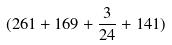Convert formula to latex. <formula><loc_0><loc_0><loc_500><loc_500>( 2 6 1 + 1 6 9 + \frac { 3 } { 2 4 } + 1 4 1 )</formula> 